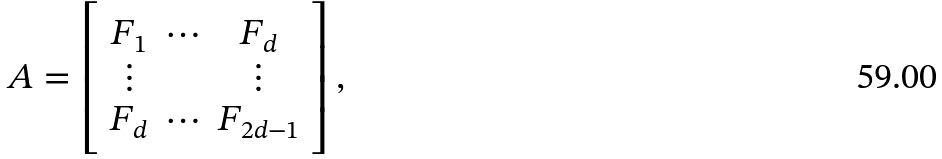Convert formula to latex. <formula><loc_0><loc_0><loc_500><loc_500>A = \left [ \begin{array} { c c c } F _ { 1 } & \cdots & F _ { d } \\ \vdots & & \vdots \\ F _ { d } & \cdots & F _ { 2 d - 1 } \end{array} \right ] ,</formula> 